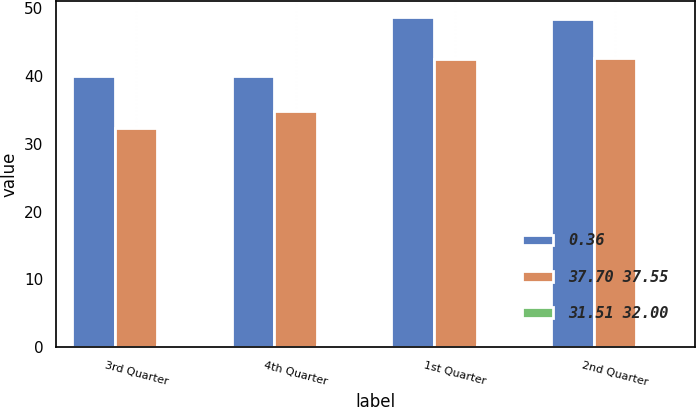Convert chart to OTSL. <chart><loc_0><loc_0><loc_500><loc_500><stacked_bar_chart><ecel><fcel>3rd Quarter<fcel>4th Quarter<fcel>1st Quarter<fcel>2nd Quarter<nl><fcel>0.36<fcel>39.98<fcel>39.96<fcel>48.7<fcel>48.43<nl><fcel>37.70 37.55<fcel>32.29<fcel>34.91<fcel>42.54<fcel>42.63<nl><fcel>31.51 32.00<fcel>0.36<fcel>0.36<fcel>0.3<fcel>0.3<nl></chart> 